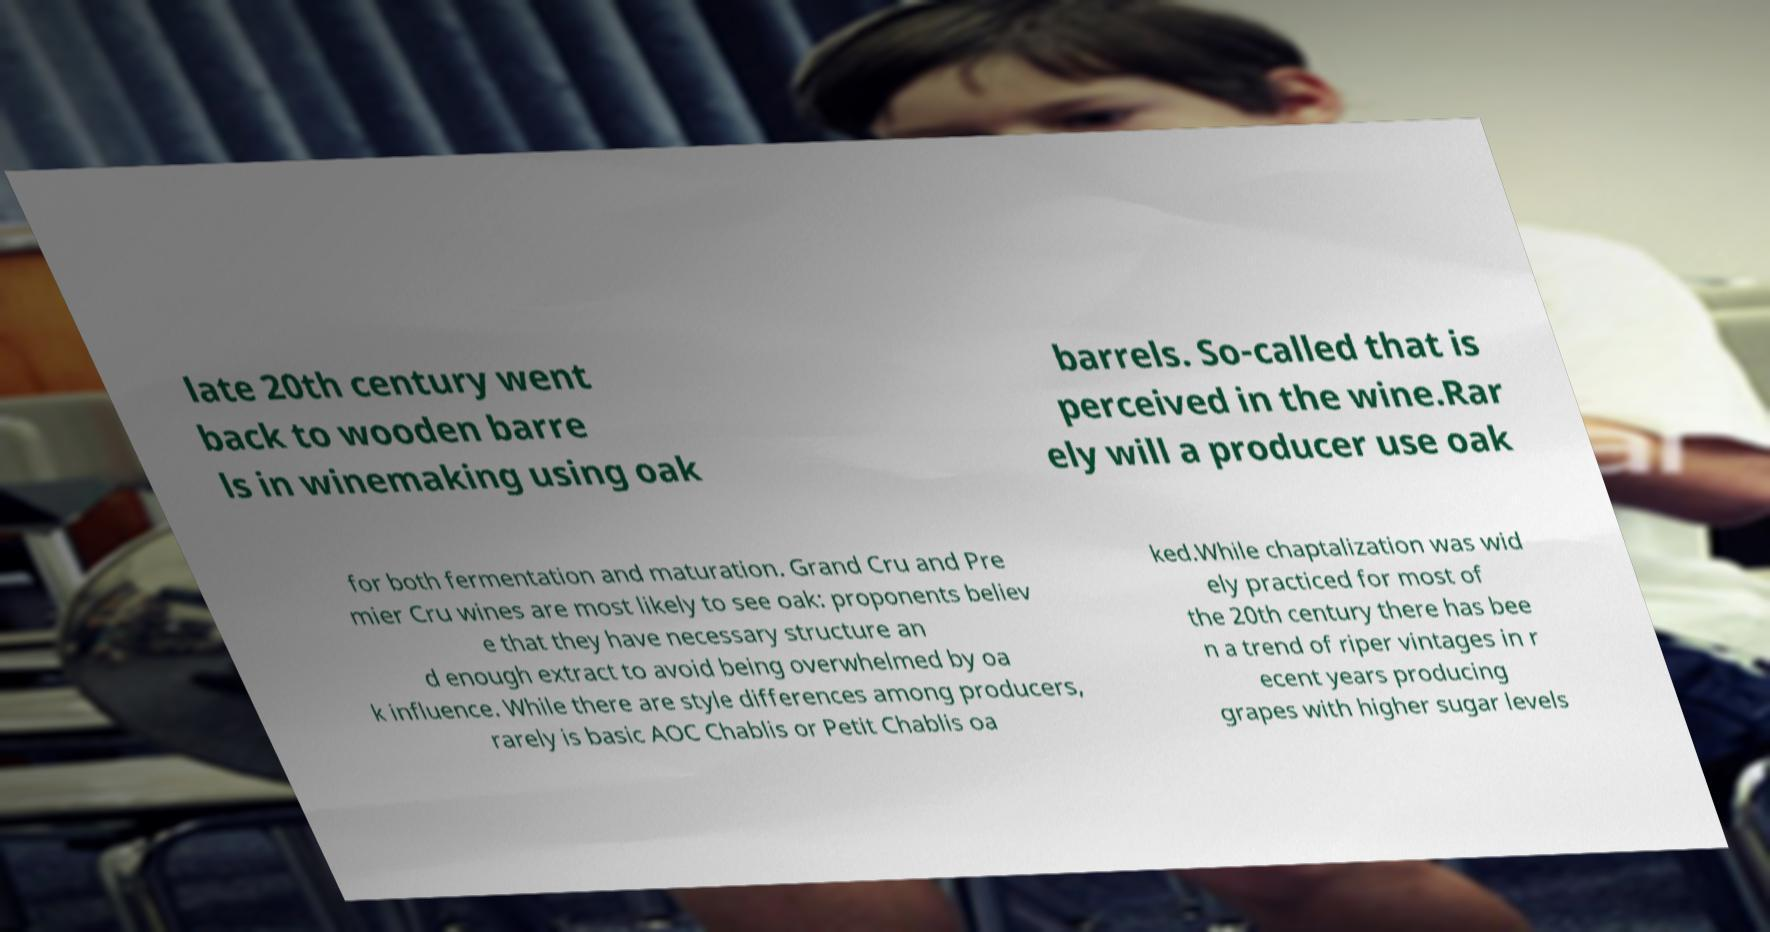What messages or text are displayed in this image? I need them in a readable, typed format. late 20th century went back to wooden barre ls in winemaking using oak barrels. So-called that is perceived in the wine.Rar ely will a producer use oak for both fermentation and maturation. Grand Cru and Pre mier Cru wines are most likely to see oak: proponents believ e that they have necessary structure an d enough extract to avoid being overwhelmed by oa k influence. While there are style differences among producers, rarely is basic AOC Chablis or Petit Chablis oa ked.While chaptalization was wid ely practiced for most of the 20th century there has bee n a trend of riper vintages in r ecent years producing grapes with higher sugar levels 